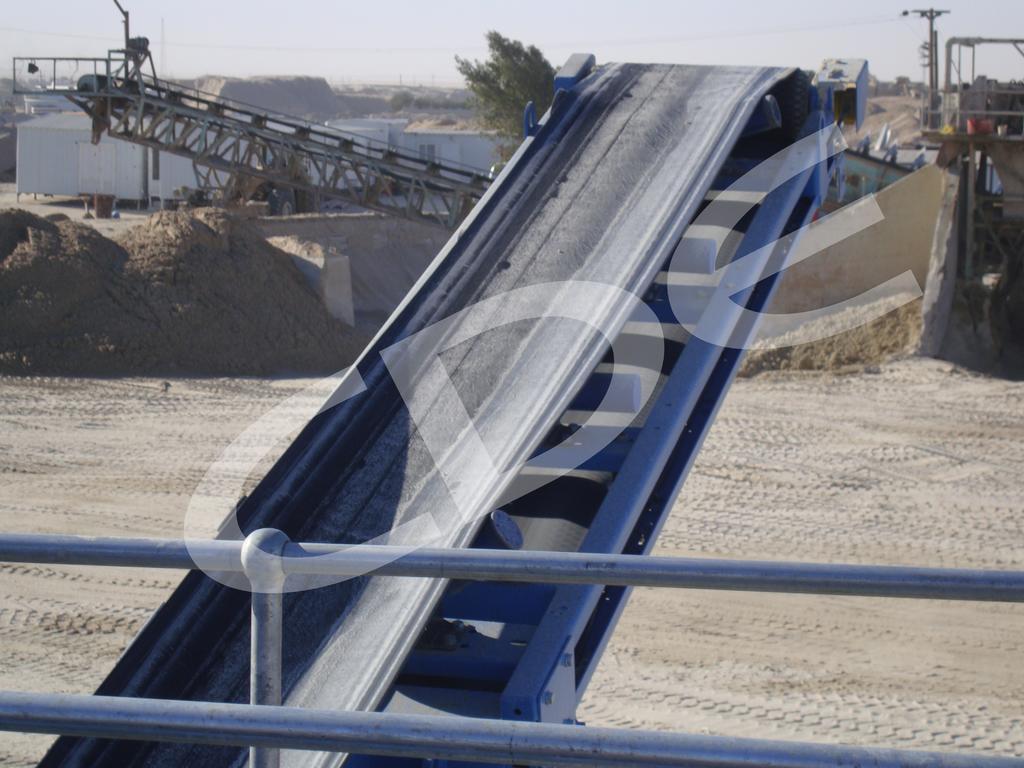Describe this image in one or two sentences. In the picture I can see the construction equipment. I can see the metal fence at the bottom of the picture. I can see the sand on the left side. I can see the metal shed house constructions on the top left side of the picture. I can see a tree at the top of the picture. 